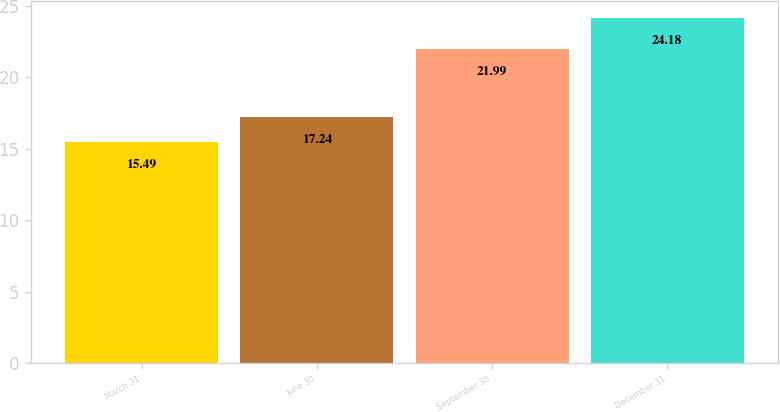<chart> <loc_0><loc_0><loc_500><loc_500><bar_chart><fcel>March 31<fcel>June 30<fcel>September 30<fcel>December 31<nl><fcel>15.49<fcel>17.24<fcel>21.99<fcel>24.18<nl></chart> 